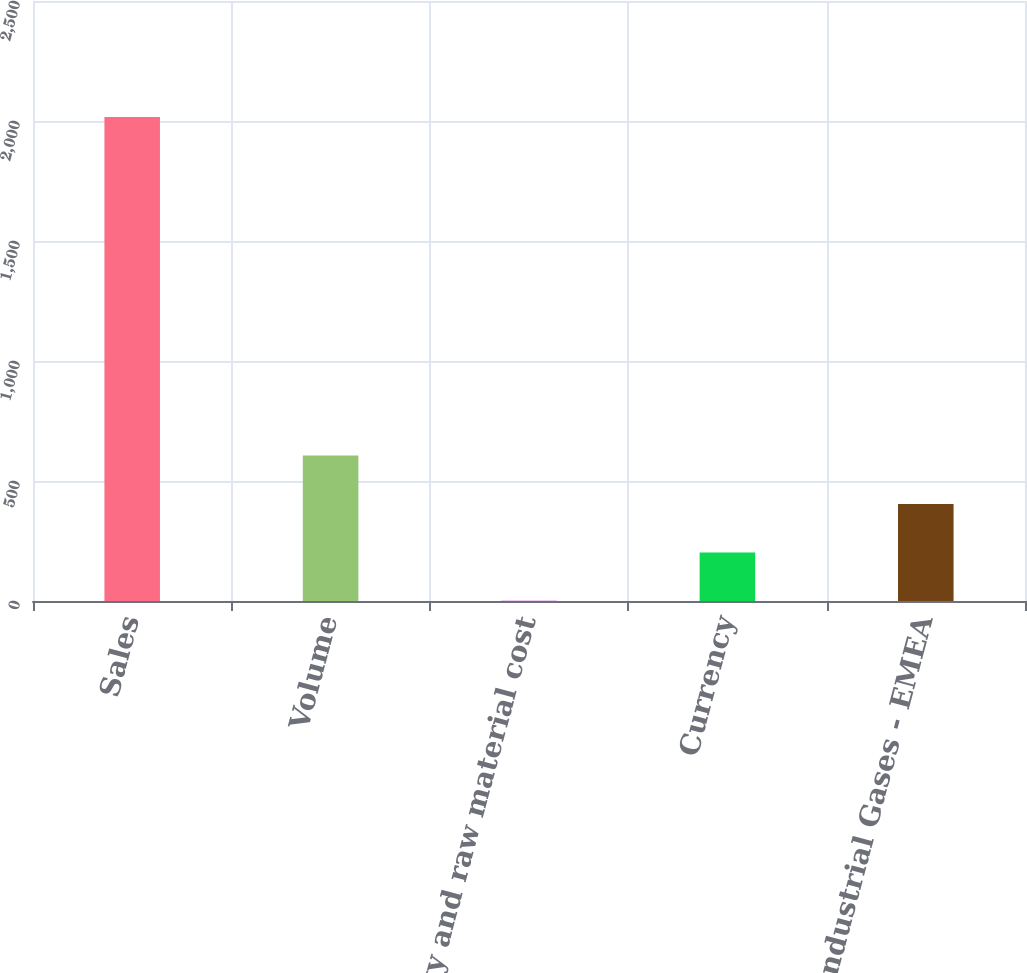Convert chart. <chart><loc_0><loc_0><loc_500><loc_500><bar_chart><fcel>Sales<fcel>Volume<fcel>Energy and raw material cost<fcel>Currency<fcel>Total Industrial Gases - EMEA<nl><fcel>2017<fcel>605.8<fcel>1<fcel>202.6<fcel>404.2<nl></chart> 